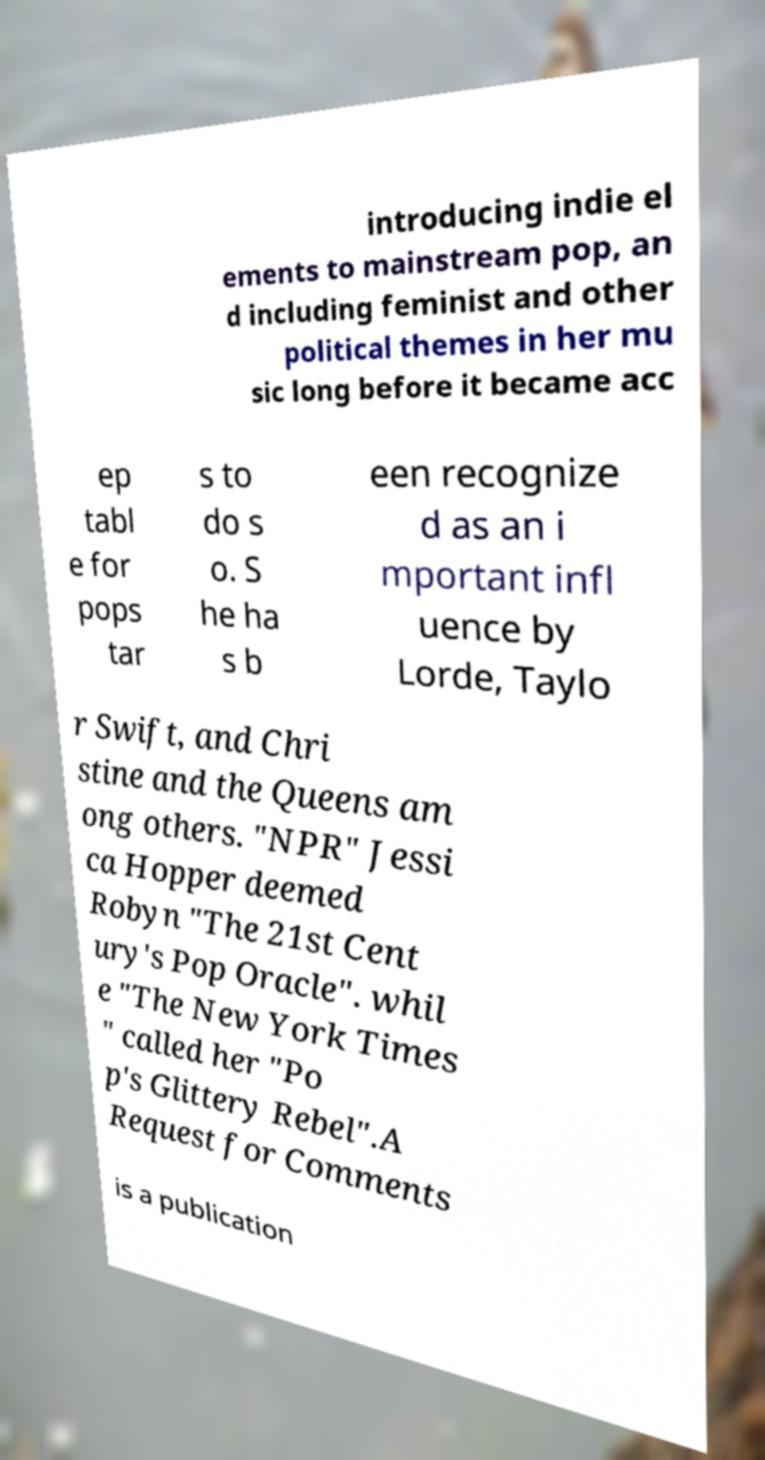Please identify and transcribe the text found in this image. introducing indie el ements to mainstream pop, an d including feminist and other political themes in her mu sic long before it became acc ep tabl e for pops tar s to do s o. S he ha s b een recognize d as an i mportant infl uence by Lorde, Taylo r Swift, and Chri stine and the Queens am ong others. "NPR" Jessi ca Hopper deemed Robyn "The 21st Cent ury's Pop Oracle". whil e "The New York Times " called her "Po p's Glittery Rebel".A Request for Comments is a publication 